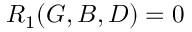Convert formula to latex. <formula><loc_0><loc_0><loc_500><loc_500>R _ { 1 } ( G , B , D ) = 0</formula> 